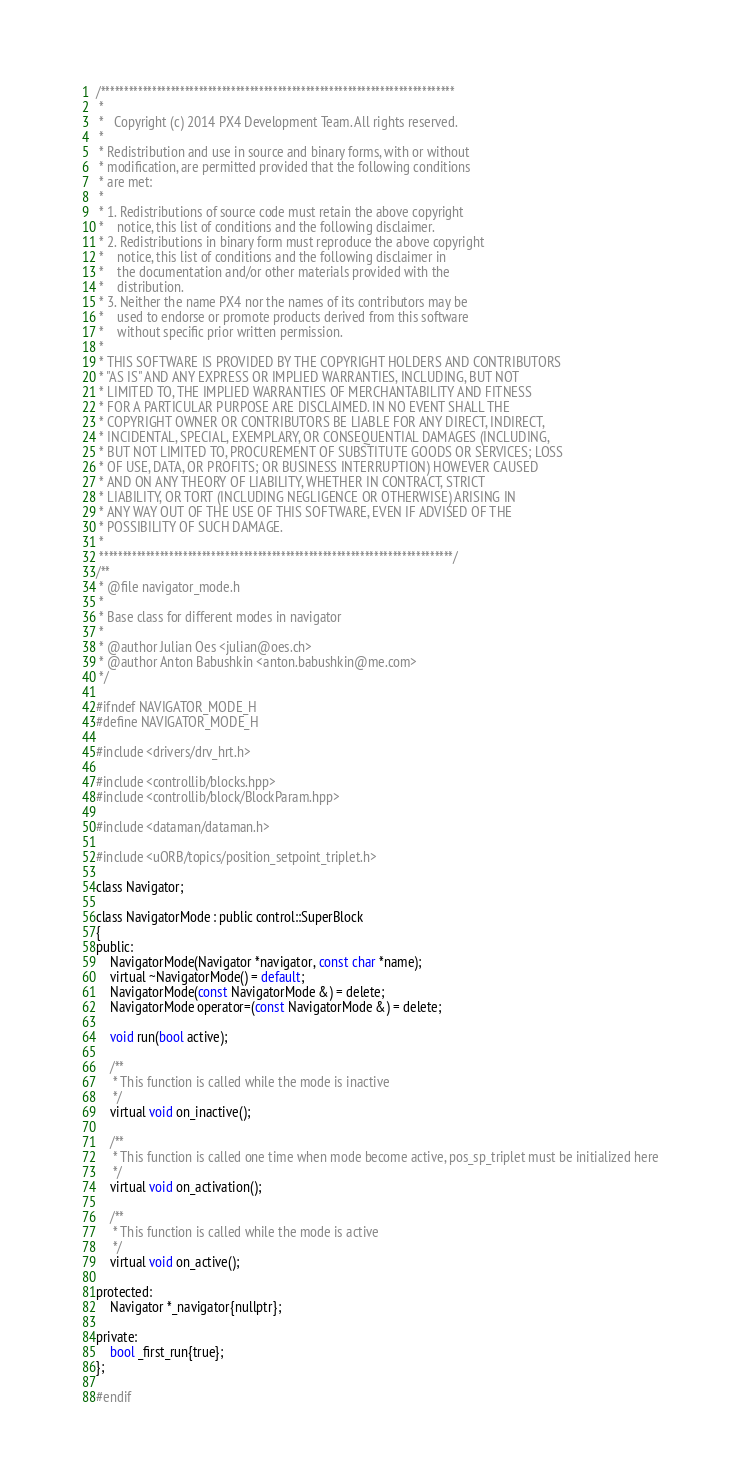<code> <loc_0><loc_0><loc_500><loc_500><_C_>/****************************************************************************
 *
 *   Copyright (c) 2014 PX4 Development Team. All rights reserved.
 *
 * Redistribution and use in source and binary forms, with or without
 * modification, are permitted provided that the following conditions
 * are met:
 *
 * 1. Redistributions of source code must retain the above copyright
 *    notice, this list of conditions and the following disclaimer.
 * 2. Redistributions in binary form must reproduce the above copyright
 *    notice, this list of conditions and the following disclaimer in
 *    the documentation and/or other materials provided with the
 *    distribution.
 * 3. Neither the name PX4 nor the names of its contributors may be
 *    used to endorse or promote products derived from this software
 *    without specific prior written permission.
 *
 * THIS SOFTWARE IS PROVIDED BY THE COPYRIGHT HOLDERS AND CONTRIBUTORS
 * "AS IS" AND ANY EXPRESS OR IMPLIED WARRANTIES, INCLUDING, BUT NOT
 * LIMITED TO, THE IMPLIED WARRANTIES OF MERCHANTABILITY AND FITNESS
 * FOR A PARTICULAR PURPOSE ARE DISCLAIMED. IN NO EVENT SHALL THE
 * COPYRIGHT OWNER OR CONTRIBUTORS BE LIABLE FOR ANY DIRECT, INDIRECT,
 * INCIDENTAL, SPECIAL, EXEMPLARY, OR CONSEQUENTIAL DAMAGES (INCLUDING,
 * BUT NOT LIMITED TO, PROCUREMENT OF SUBSTITUTE GOODS OR SERVICES; LOSS
 * OF USE, DATA, OR PROFITS; OR BUSINESS INTERRUPTION) HOWEVER CAUSED
 * AND ON ANY THEORY OF LIABILITY, WHETHER IN CONTRACT, STRICT
 * LIABILITY, OR TORT (INCLUDING NEGLIGENCE OR OTHERWISE) ARISING IN
 * ANY WAY OUT OF THE USE OF THIS SOFTWARE, EVEN IF ADVISED OF THE
 * POSSIBILITY OF SUCH DAMAGE.
 *
 ****************************************************************************/
/**
 * @file navigator_mode.h
 *
 * Base class for different modes in navigator
 *
 * @author Julian Oes <julian@oes.ch>
 * @author Anton Babushkin <anton.babushkin@me.com>
 */

#ifndef NAVIGATOR_MODE_H
#define NAVIGATOR_MODE_H

#include <drivers/drv_hrt.h>

#include <controllib/blocks.hpp>
#include <controllib/block/BlockParam.hpp>

#include <dataman/dataman.h>

#include <uORB/topics/position_setpoint_triplet.h>

class Navigator;

class NavigatorMode : public control::SuperBlock
{
public:
	NavigatorMode(Navigator *navigator, const char *name);
	virtual ~NavigatorMode() = default;
	NavigatorMode(const NavigatorMode &) = delete;
	NavigatorMode operator=(const NavigatorMode &) = delete;

	void run(bool active);

	/**
	 * This function is called while the mode is inactive
	 */
	virtual void on_inactive();

	/**
	 * This function is called one time when mode become active, pos_sp_triplet must be initialized here
	 */
	virtual void on_activation();

	/**
	 * This function is called while the mode is active
	 */
	virtual void on_active();

protected:
	Navigator *_navigator{nullptr};

private:
	bool _first_run{true};
};

#endif
</code> 